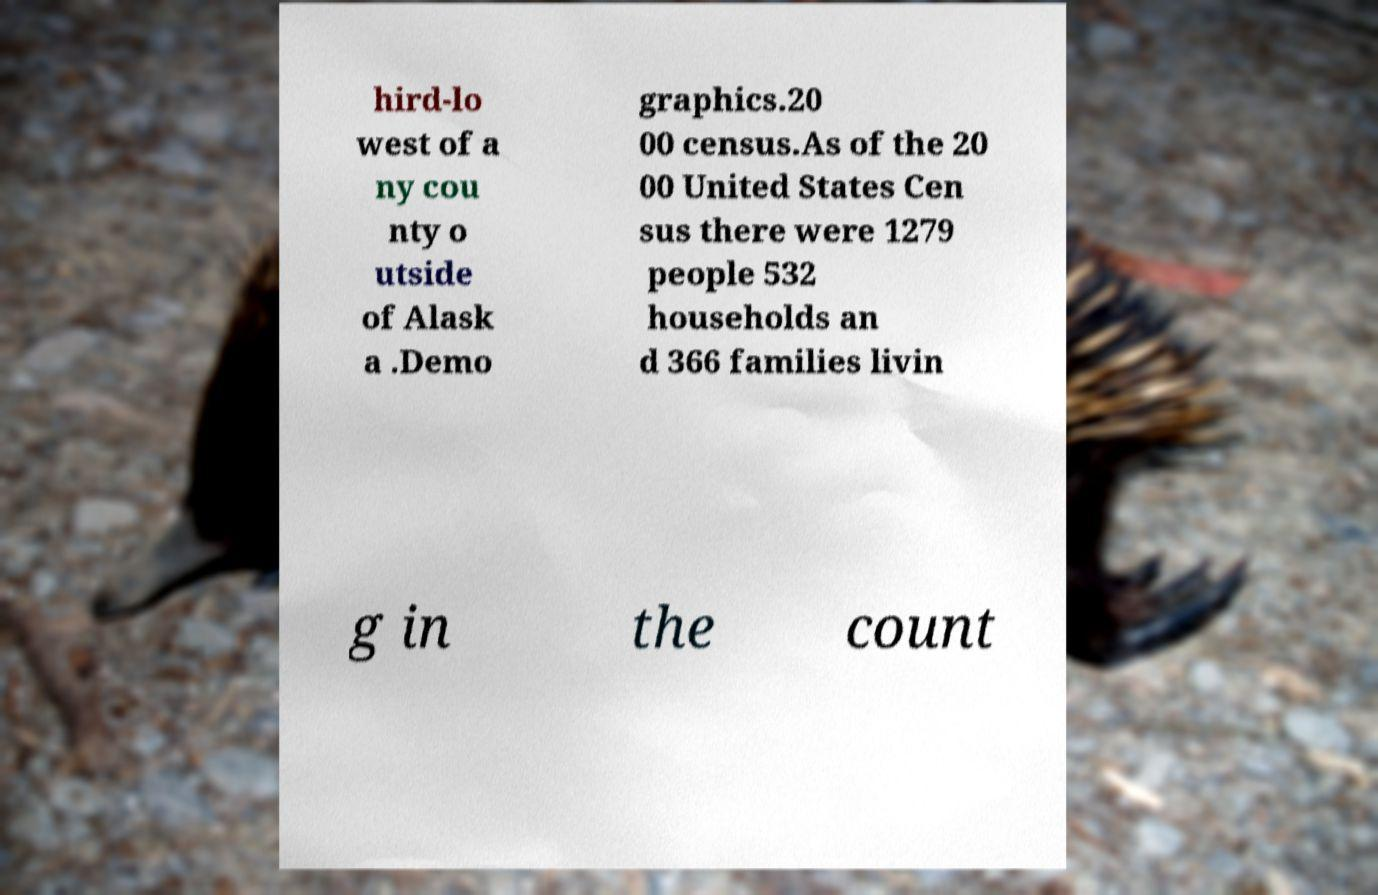Can you read and provide the text displayed in the image?This photo seems to have some interesting text. Can you extract and type it out for me? hird-lo west of a ny cou nty o utside of Alask a .Demo graphics.20 00 census.As of the 20 00 United States Cen sus there were 1279 people 532 households an d 366 families livin g in the count 